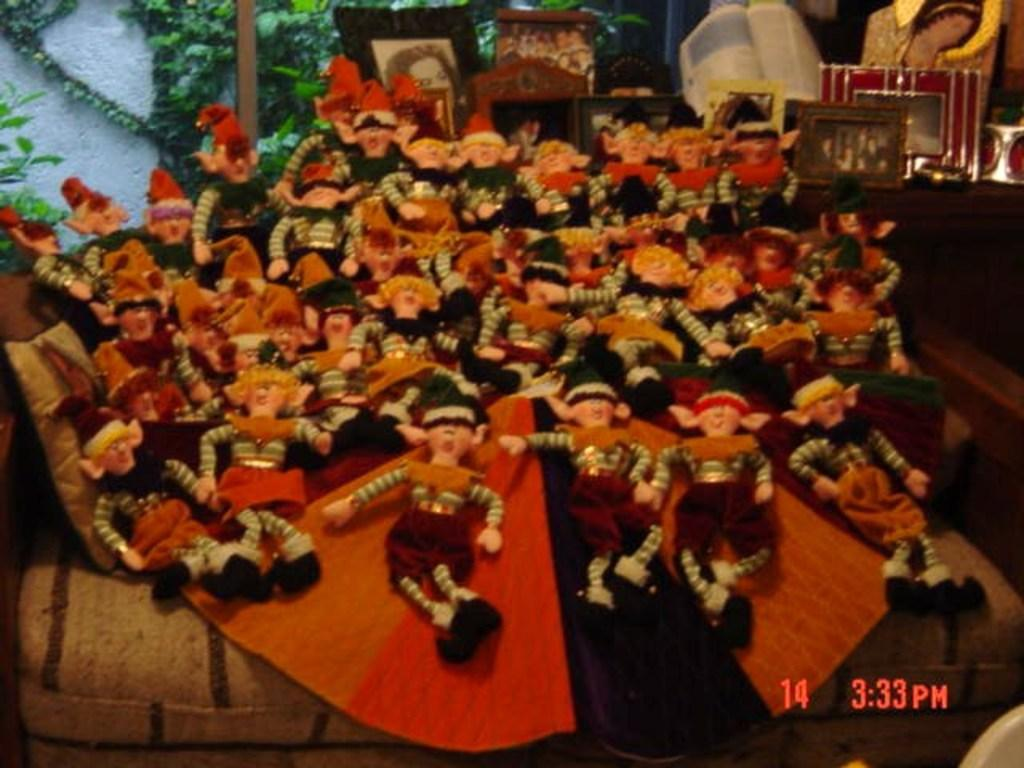What is present in the image in a group? There is a group of dolls in the image. What type of artistic representation can be seen in the image? There is an image drawing in the image. What object related to reading can be seen in the image? There is a book in the image. What type of natural vegetation is visible in the image? There are trees in the image. What type of rake is being used to push the dolls in the image? There is no rake or pushing of dolls present in the image. What type of song is being sung by the dolls in the image? There is no song or singing by dolls present in the image. 